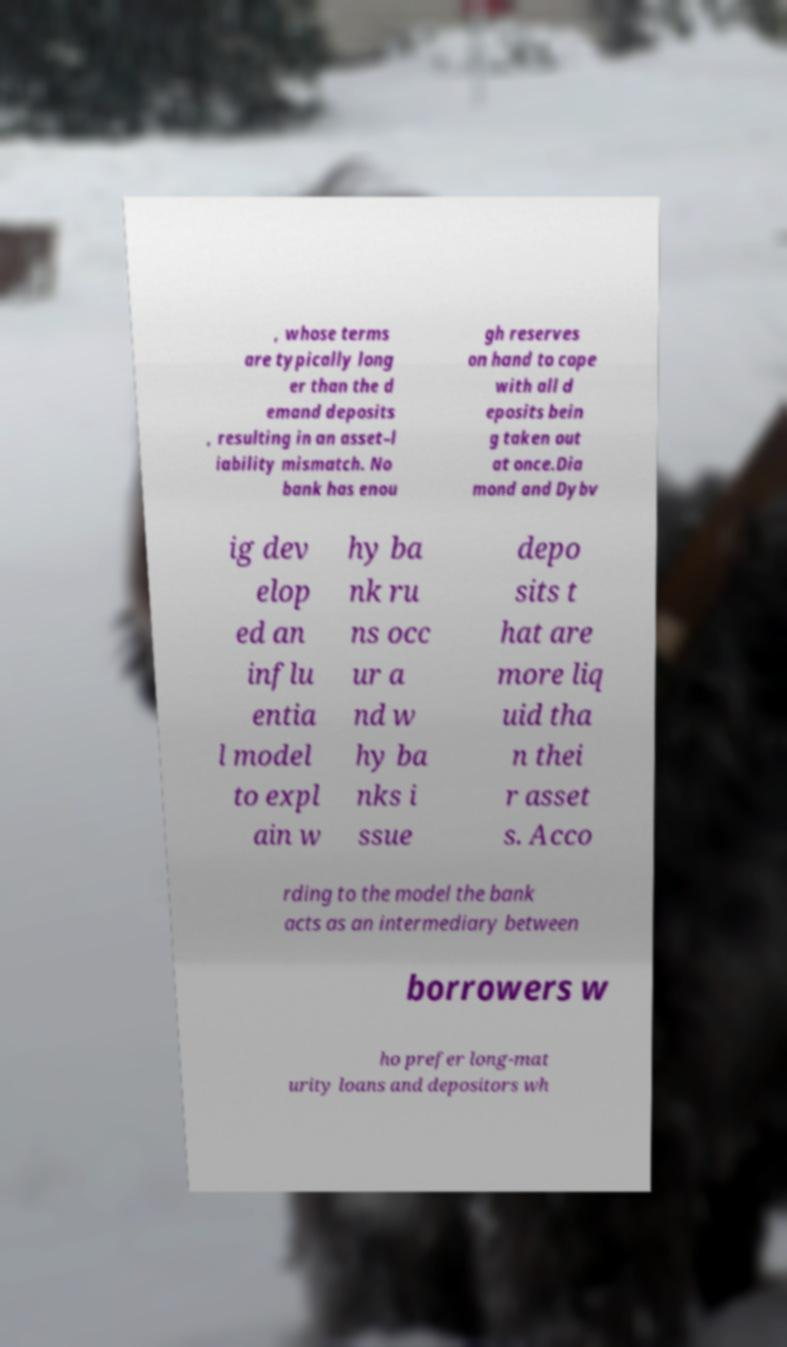There's text embedded in this image that I need extracted. Can you transcribe it verbatim? , whose terms are typically long er than the d emand deposits , resulting in an asset–l iability mismatch. No bank has enou gh reserves on hand to cope with all d eposits bein g taken out at once.Dia mond and Dybv ig dev elop ed an influ entia l model to expl ain w hy ba nk ru ns occ ur a nd w hy ba nks i ssue depo sits t hat are more liq uid tha n thei r asset s. Acco rding to the model the bank acts as an intermediary between borrowers w ho prefer long-mat urity loans and depositors wh 